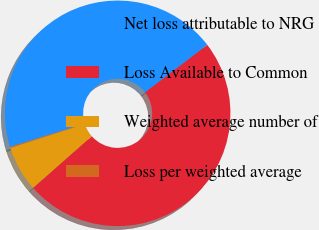Convert chart to OTSL. <chart><loc_0><loc_0><loc_500><loc_500><pie_chart><fcel>Net loss attributable to NRG<fcel>Loss Available to Common<fcel>Weighted average number of<fcel>Loss per weighted average<nl><fcel>44.44%<fcel>48.87%<fcel>6.54%<fcel>0.14%<nl></chart> 